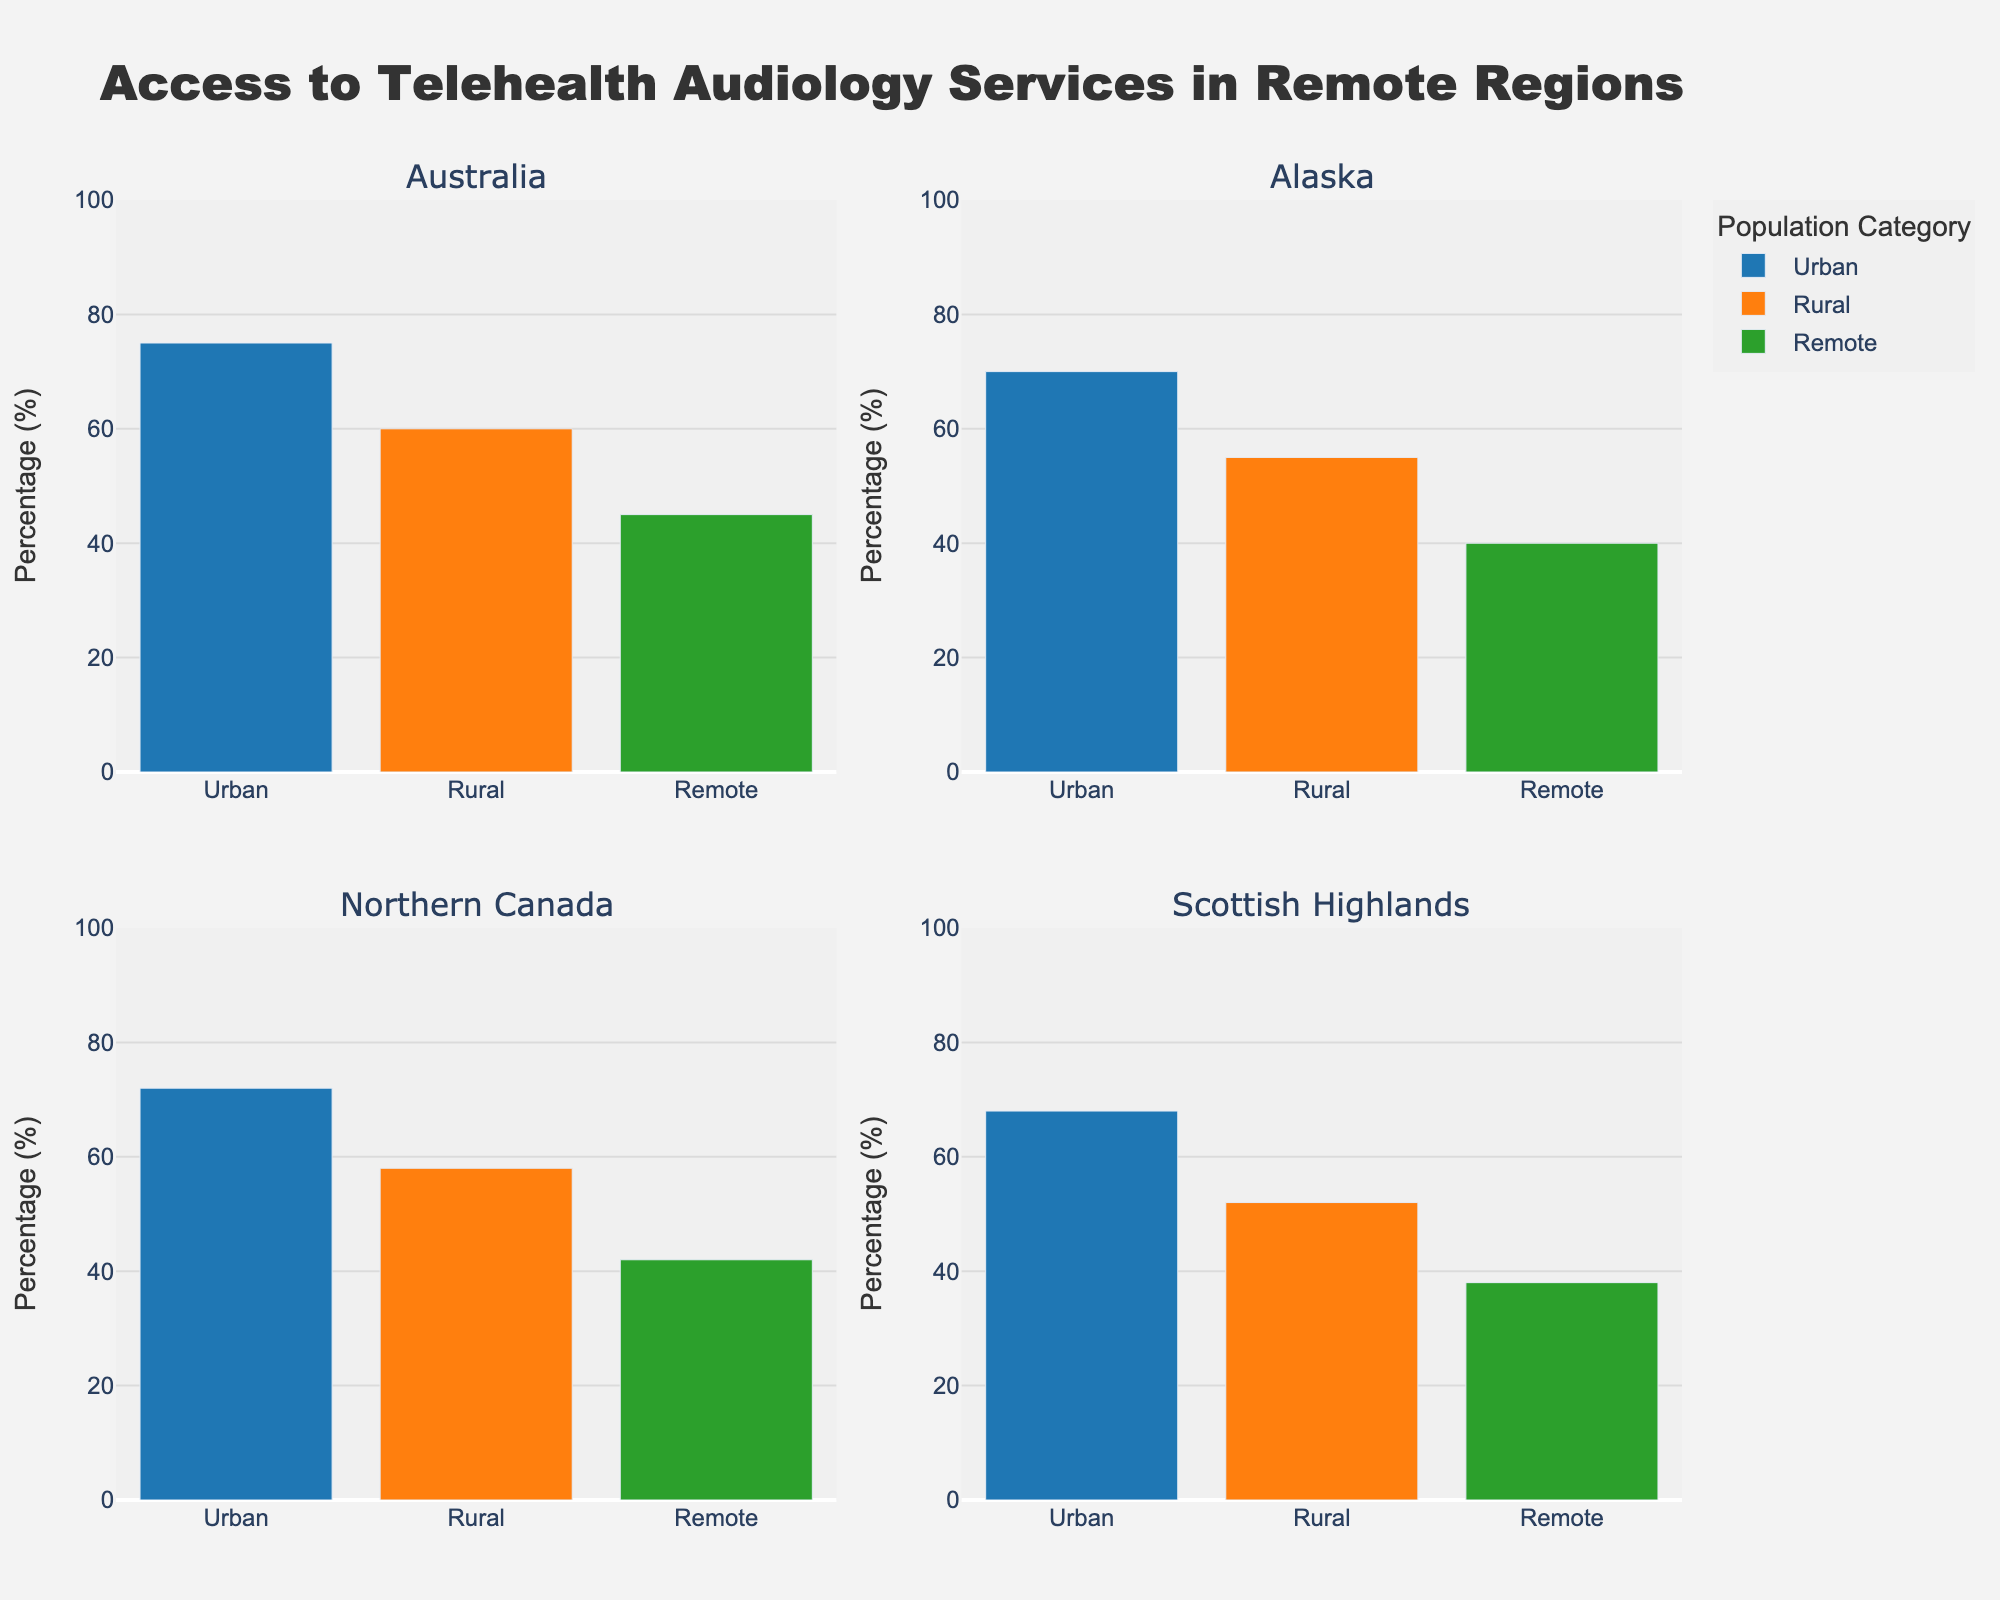what is the title of the figure? The title of the figure is typically located at the top center of the plot and it provides an overview of what the figure represents. According to the code, the title is set as "Access to Telehealth Audiology Services in Remote Regions".
Answer: Access to Telehealth Audiology Services in Remote Regions which region has the highest percentage of urban population with access to telehealth audiology services among the shown regions? To find the region with the highest percentage of urban population with access to telehealth audiology services, we compare the urban bars in all subplots. According to the data, the largest urban percentage among the discussed regions is 75% for Australia.
Answer: Australia what is the percentage difference in rural population with access to telehealth audiology services between the region with the highest and the lowest percentages? First, identify the highest and lowest percentages for rural populations in the shown regions. The highest is 60% in Australia and the lowest is 32% in Papua New Guinea. The difference is 60% - 32% = 28%.
Answer: 28% which region has a higher percentage of remote population with access to telehealth services, Scottish Highlands or Himalayan Range, and by how much? Comparing the remote percentage bars for Scottish Highlands (38%) and Himalayan Range (25%), we subtract the smaller value from the larger one, which gives us 38% - 25% = 13%.
Answer: Scottish Highlands, 13% of the regions shown, how many have at least 50% of the urban population with access to telehealth audiology services? To determine the number of regions where at least 50% of the urban population has access, we count the regions with urban percentages of 50% or more: Australia (75%), Alaska (70%), Northern Canada (72%), Scottish Highlands (68%), Siberia (65%), Arctic Greenland (60%). This results in 6 regions.
Answer: 6 how does the percentage of urban population with access to telehealth services in Alaska compare to the rural population in Siberia? From the figure, the urban population in Alaska with access is 70%, and the rural population in Siberia is 48%. Thus, Alaska's urban access percentage is 22% higher than the rural percentage in Siberia.
Answer: Alaska's urban is 22% higher which category (urban, rural, remote) generally has the lowest percentage of population with access to telehealth audiology services across all shown regions? By scanning the bars of each category across all subplots, it's evident that the "Remote" category generally has the lowest percentage of population with access to telehealth audiology services.
Answer: Remote what is the average percentage of the rural population with access to telehealth services in the first four regions? The rural populations for the first four regions are: Australia (60%), Alaska (55%), Northern Canada (58%), and Scottish Highlands (52%). The average can be calculated as (60 + 55 + 58 + 52) / 4 = 225 / 4 = 56.25%.
Answer: 56.25% 